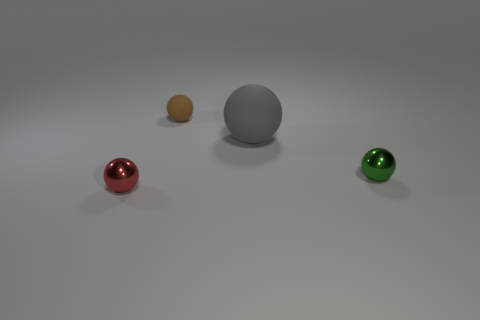Subtract all red balls. How many balls are left? 3 Subtract all small red metallic balls. How many balls are left? 3 Add 4 big purple shiny cylinders. How many objects exist? 8 Subtract 1 balls. How many balls are left? 3 Subtract all purple balls. Subtract all cyan cylinders. How many balls are left? 4 Add 3 large gray balls. How many large gray balls exist? 4 Subtract 0 blue balls. How many objects are left? 4 Subtract all brown things. Subtract all small rubber things. How many objects are left? 2 Add 3 small green metal objects. How many small green metal objects are left? 4 